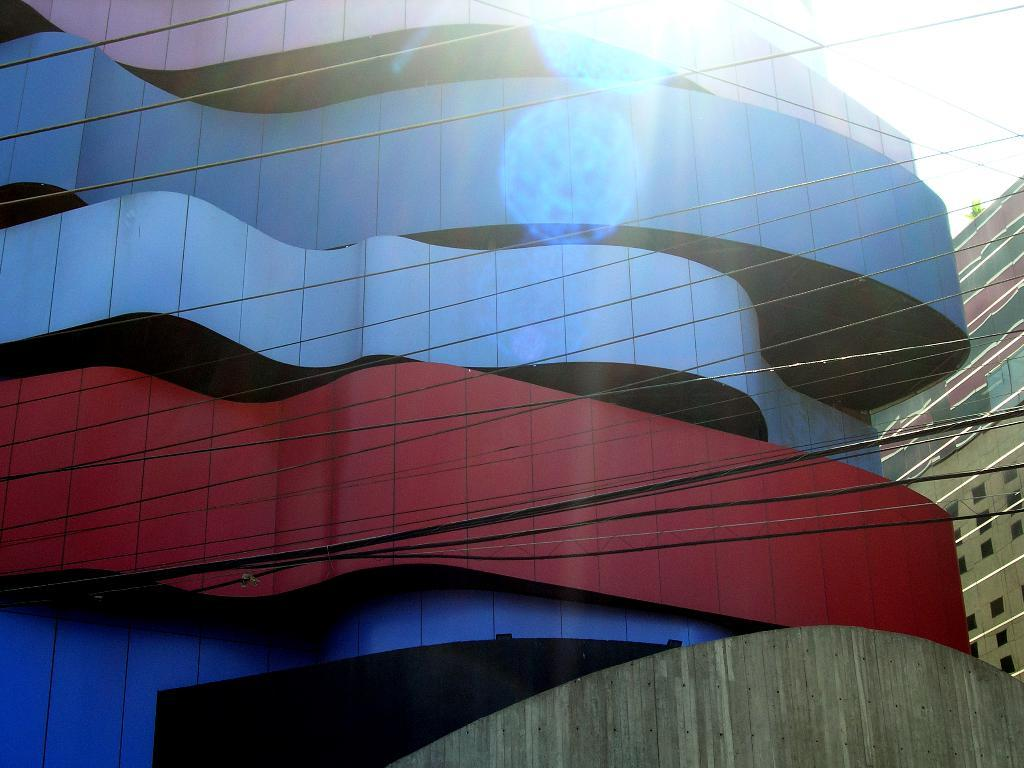What type of structures can be seen in the image? There are buildings in the image. What else is visible in the image besides the buildings? Wires are visible in the image. How would you describe the sky in the image? The sky is cloudy in the image. What type of religious symbol can be seen on the roof of the building in the image? There is no religious symbol visible on the roof of the building in the image. How much sugar is present in the image? There is no sugar present in the image. 